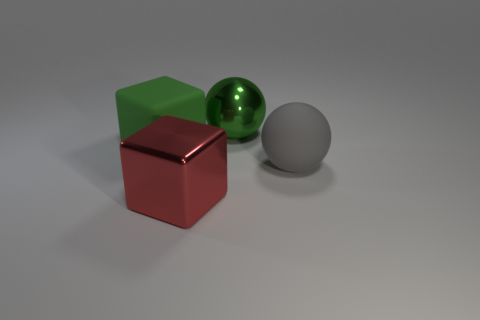What is the large sphere that is to the left of the big sphere in front of the metal object behind the large gray ball made of?
Your answer should be compact. Metal. What is the material of the gray ball?
Ensure brevity in your answer.  Rubber. The green object that is the same shape as the gray matte object is what size?
Offer a terse response. Large. Do the matte ball and the metallic ball have the same color?
Your answer should be compact. No. Is the number of big red objects behind the large gray thing the same as the number of large gray matte balls?
Ensure brevity in your answer.  No. Is the size of the shiny thing behind the red metal thing the same as the gray ball?
Your answer should be very brief. Yes. There is a big green metallic thing; how many gray objects are on the left side of it?
Offer a terse response. 0. There is a large thing that is in front of the big green block and behind the red metallic cube; what is its material?
Provide a succinct answer. Rubber. What number of tiny things are red metal cylinders or green matte objects?
Your answer should be very brief. 0. What size is the red cube?
Give a very brief answer. Large. 